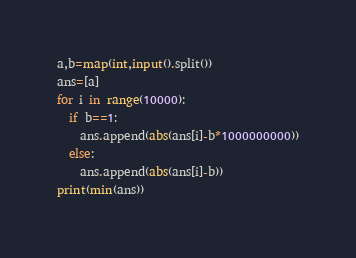Convert code to text. <code><loc_0><loc_0><loc_500><loc_500><_Python_>a,b=map(int,input().split())
ans=[a]
for i in range(10000):
  if b==1:
    ans.append(abs(ans[i]-b*1000000000))
  else:
    ans.append(abs(ans[i]-b))
print(min(ans))</code> 